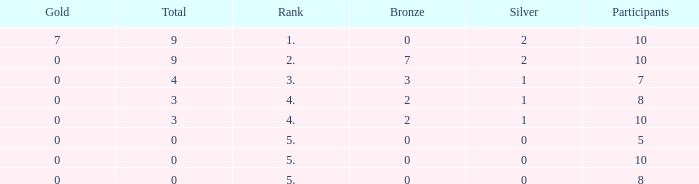What is listed as the highest Participants that also have a Rank of 5, and Silver that's smaller than 0? None. 